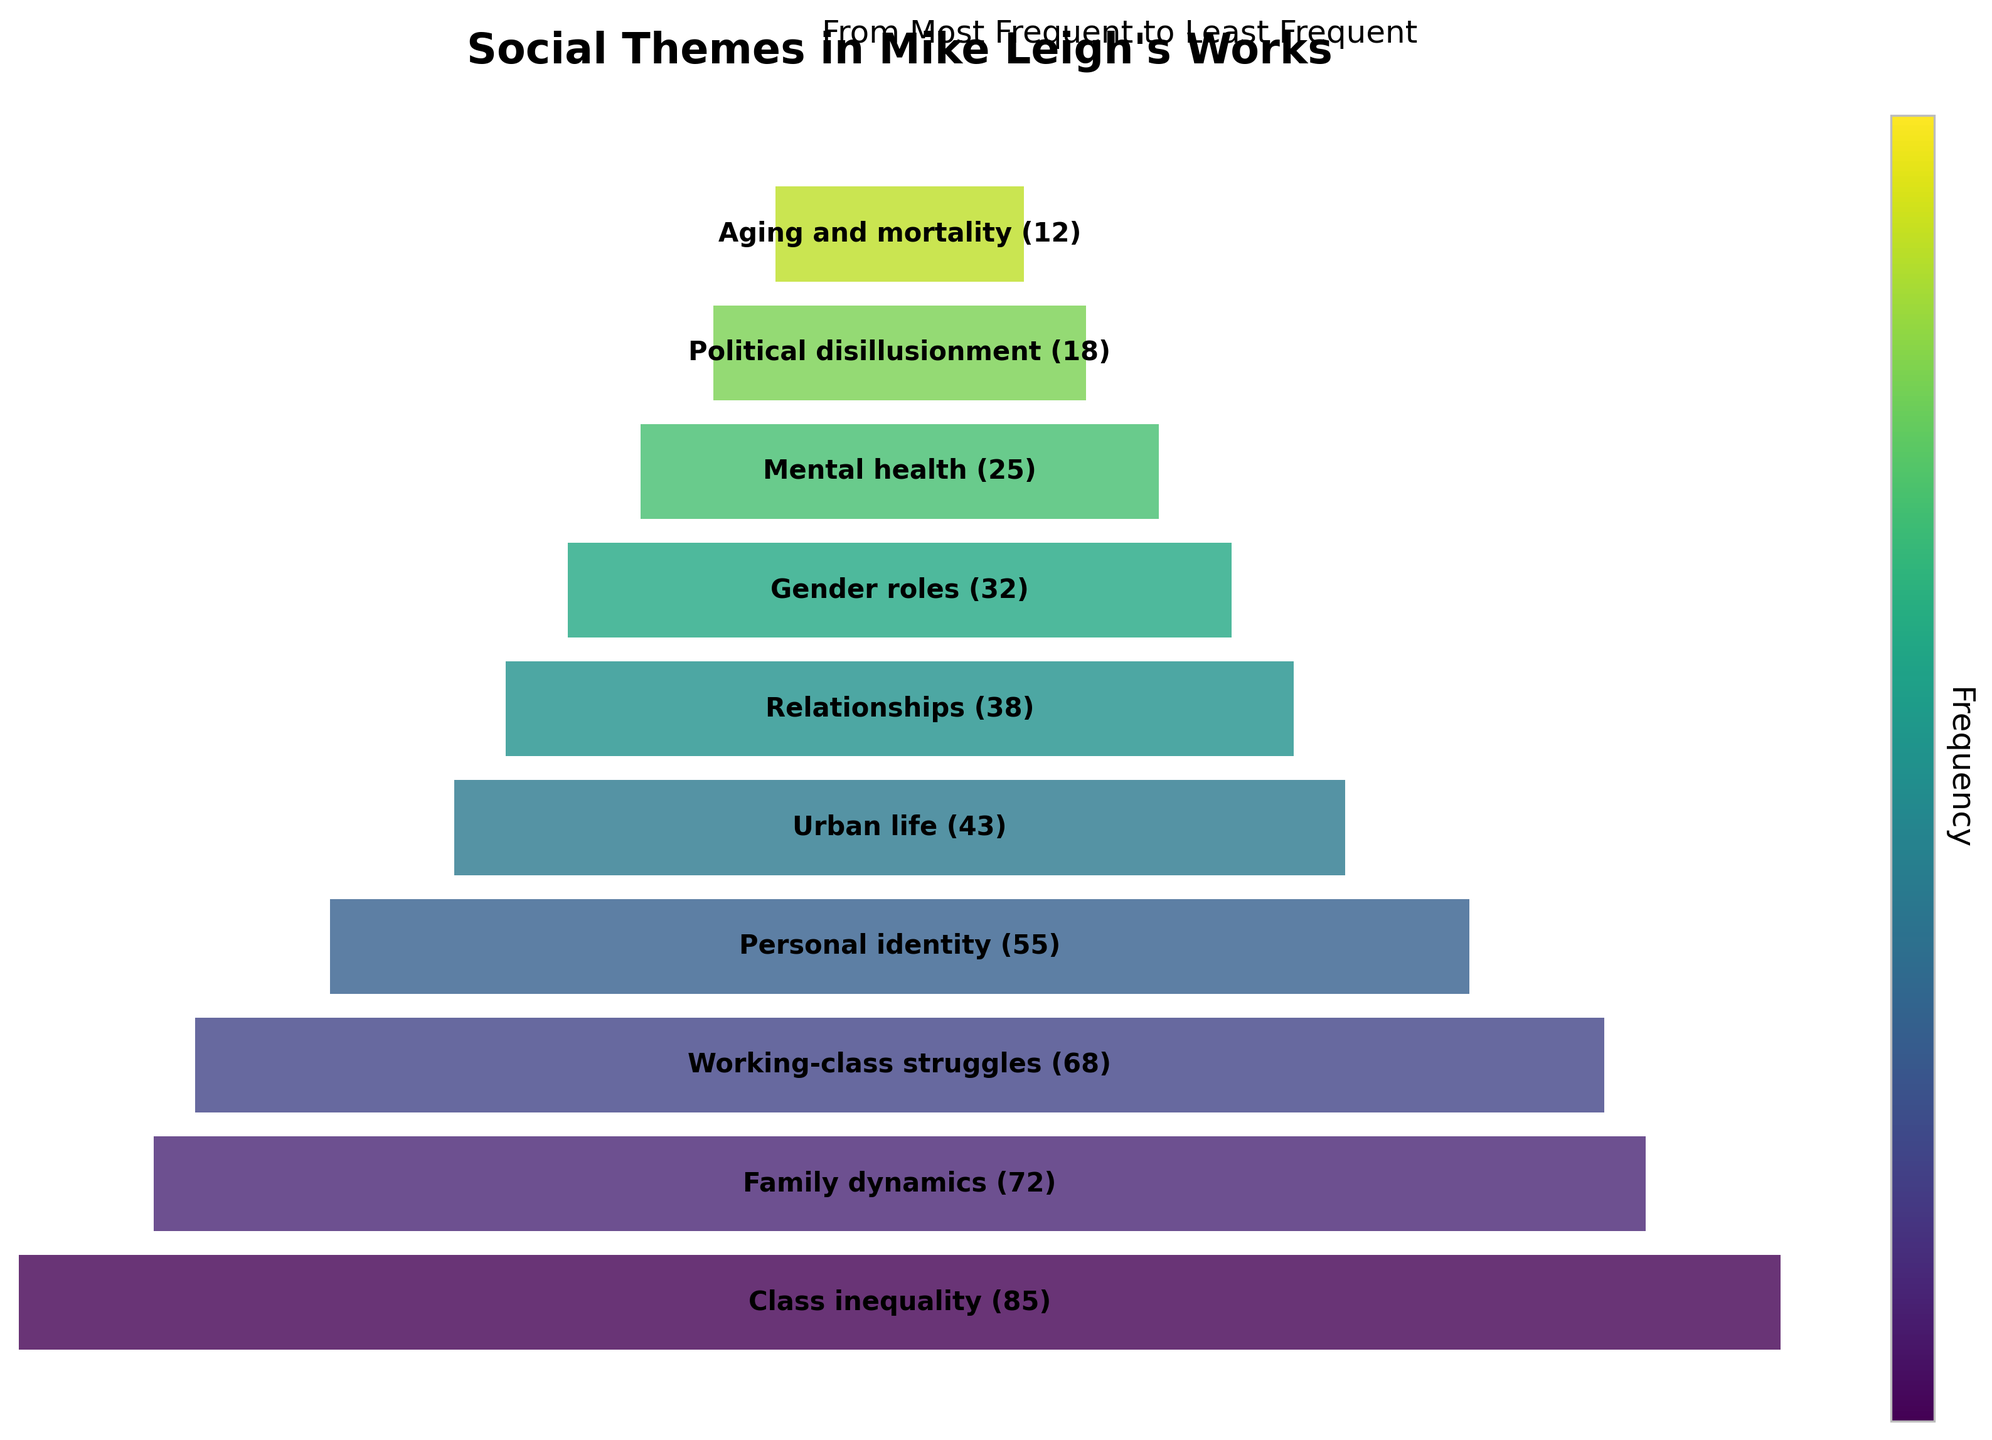What's the most frequent social theme in Mike Leigh's works? The highest bar in the funnel chart indicates the most frequent theme. It is labeled "Class inequality (85)" at the top of the chart.
Answer: Class inequality What's the least frequent social theme highlighted? The smallest bar at the bottom of the chart reveals the least frequent theme labeled "Aging and mortality (12)".
Answer: Aging and mortality How many themes address family dynamics? By looking at the chart, the theme "Family dynamics" is prominently labeled with a frequency of "72".
Answer: 72 Which theme related to societal struggles comes second to "Class inequality"? From visual observation, "Family dynamics" follows "Class inequality". However, the second societal struggle theme after "Class inequality" is "Working-class struggles" with a frequency of 68.
Answer: Working-class struggles What's the total frequency of themes related to identity and mental health? Add the frequencies of "Personal identity (55)" and "Mental health (25)". Together, they sum to 55 + 25 = 80.
Answer: 80 Which theme has a frequency greater than "Urban life" but less than "Family dynamics"? "Urban life" has a frequency of "43" and "Family dynamics" has "72". The theme fitting this range is "Personal identity" with "55".
Answer: Personal identity If combined, how frequent are themes related to family and relationships? The frequencies for "Family dynamics (72)" and "Relationships (38)" sum up to 72 + 38 = 110.
Answer: 110 How does the frequency of "Gender roles" compare to "Working-class struggles"? "Gender roles" has a lower frequency of "32", compared to "Working-class struggles" which has "68".
Answer: Gender roles is less frequent What's the median frequency among these themes? Arrange frequencies in ascending order: 12, 18, 25, 32, 38, 43, 55, 68, 72, 85. The median is the middle value for an odd number of values, which is the 5th and 6th values averaged, (38 + 43) / 2 = 40.5.
Answer: 40.5 How much more frequent is "Class inequality" compared to "Political disillusionment"? Subtract the frequency of "Political disillusionment (18)" from "Class inequality (85)". 85 - 18 = 67.
Answer: 67 